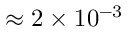Convert formula to latex. <formula><loc_0><loc_0><loc_500><loc_500>\approx 2 \times 1 0 ^ { - 3 }</formula> 